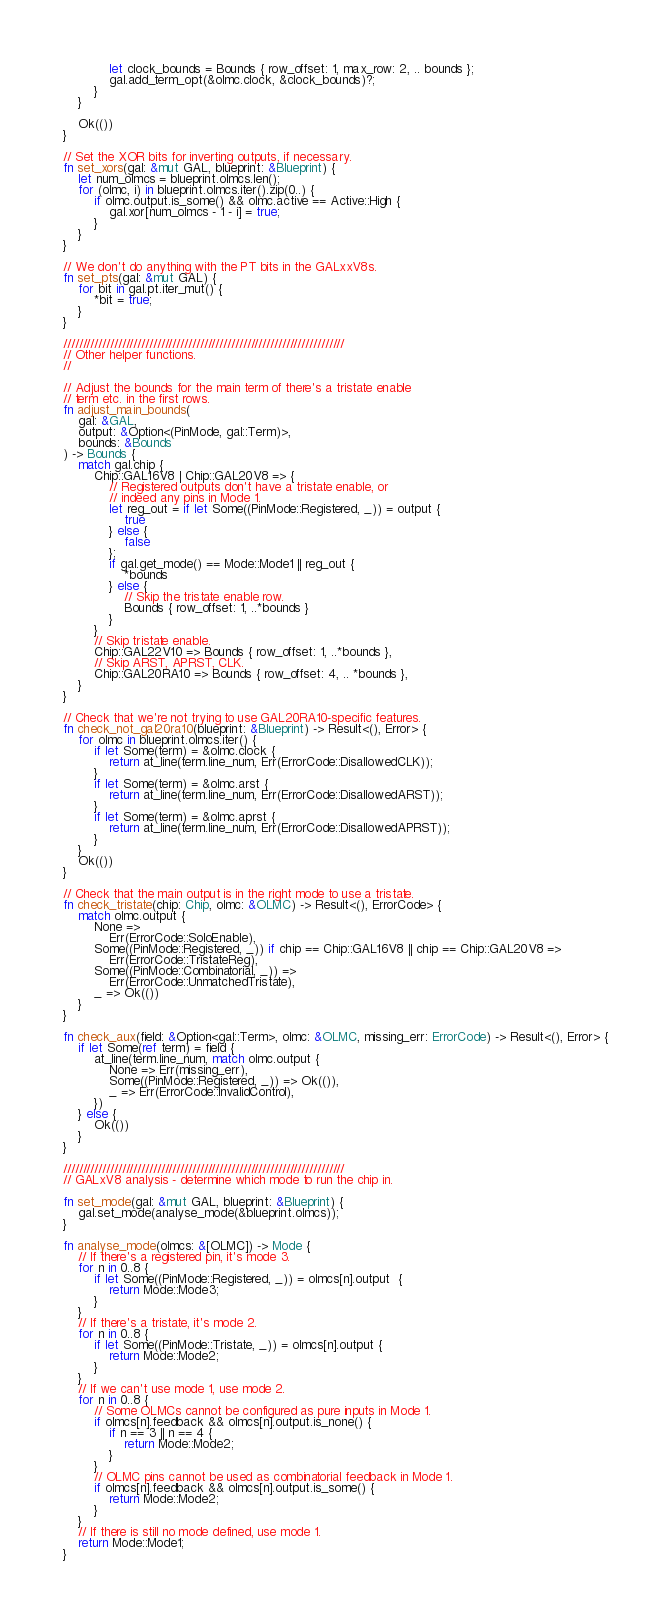Convert code to text. <code><loc_0><loc_0><loc_500><loc_500><_Rust_>            let clock_bounds = Bounds { row_offset: 1, max_row: 2, .. bounds };
            gal.add_term_opt(&olmc.clock, &clock_bounds)?;
        }
    }

    Ok(())
}

// Set the XOR bits for inverting outputs, if necessary.
fn set_xors(gal: &mut GAL, blueprint: &Blueprint) {
    let num_olmcs = blueprint.olmcs.len();
    for (olmc, i) in blueprint.olmcs.iter().zip(0..) {
        if olmc.output.is_some() && olmc.active == Active::High {
            gal.xor[num_olmcs - 1 - i] = true;
        }
    }
}

// We don't do anything with the PT bits in the GALxxV8s.
fn set_pts(gal: &mut GAL) {
    for bit in gal.pt.iter_mut() {
        *bit = true;
    }
}

////////////////////////////////////////////////////////////////////////
// Other helper functions.
//

// Adjust the bounds for the main term of there's a tristate enable
// term etc. in the first rows.
fn adjust_main_bounds(
    gal: &GAL,
    output: &Option<(PinMode, gal::Term)>,
    bounds: &Bounds
) -> Bounds {
    match gal.chip {
        Chip::GAL16V8 | Chip::GAL20V8 => {
            // Registered outputs don't have a tristate enable, or
            // indeed any pins in Mode 1.
            let reg_out = if let Some((PinMode::Registered, _)) = output {
                true
            } else {
                false
            };
            if gal.get_mode() == Mode::Mode1 || reg_out {
                *bounds
            } else {
                // Skip the tristate enable row.
                Bounds { row_offset: 1, ..*bounds }
            }
        }
        // Skip tristate enable.
        Chip::GAL22V10 => Bounds { row_offset: 1, ..*bounds },
        // Skip ARST, APRST, CLK.
        Chip::GAL20RA10 => Bounds { row_offset: 4, .. *bounds },
    }
}

// Check that we're not trying to use GAL20RA10-specific features.
fn check_not_gal20ra10(blueprint: &Blueprint) -> Result<(), Error> {
    for olmc in blueprint.olmcs.iter() {
        if let Some(term) = &olmc.clock {
            return at_line(term.line_num, Err(ErrorCode::DisallowedCLK));
        }
        if let Some(term) = &olmc.arst {
            return at_line(term.line_num, Err(ErrorCode::DisallowedARST));
        }
        if let Some(term) = &olmc.aprst {
            return at_line(term.line_num, Err(ErrorCode::DisallowedAPRST));
        }
    }
    Ok(())
}

// Check that the main output is in the right mode to use a tristate.
fn check_tristate(chip: Chip, olmc: &OLMC) -> Result<(), ErrorCode> {
    match olmc.output {
        None =>
            Err(ErrorCode::SoloEnable),
        Some((PinMode::Registered, _)) if chip == Chip::GAL16V8 || chip == Chip::GAL20V8 =>
            Err(ErrorCode::TristateReg),
        Some((PinMode::Combinatorial, _)) =>
            Err(ErrorCode::UnmatchedTristate),
        _ => Ok(())
    }
}

fn check_aux(field: &Option<gal::Term>, olmc: &OLMC, missing_err: ErrorCode) -> Result<(), Error> {
    if let Some(ref term) = field {
        at_line(term.line_num, match olmc.output {
            None => Err(missing_err),
            Some((PinMode::Registered, _)) => Ok(()),
            _ => Err(ErrorCode::InvalidControl),
        })
    } else {
        Ok(())
    }
}

////////////////////////////////////////////////////////////////////////
// GALxV8 analysis - determine which mode to run the chip in.

fn set_mode(gal: &mut GAL, blueprint: &Blueprint) {
    gal.set_mode(analyse_mode(&blueprint.olmcs));
}

fn analyse_mode(olmcs: &[OLMC]) -> Mode {
    // If there's a registered pin, it's mode 3.
    for n in 0..8 {
        if let Some((PinMode::Registered, _)) = olmcs[n].output  {
            return Mode::Mode3;
        }
    }
    // If there's a tristate, it's mode 2.
    for n in 0..8 {
        if let Some((PinMode::Tristate, _)) = olmcs[n].output {
            return Mode::Mode2;
        }
    }
    // If we can't use mode 1, use mode 2.
    for n in 0..8 {
        // Some OLMCs cannot be configured as pure inputs in Mode 1.
        if olmcs[n].feedback && olmcs[n].output.is_none() {
            if n == 3 || n == 4 {
                return Mode::Mode2;
            }
        }
        // OLMC pins cannot be used as combinatorial feedback in Mode 1.
        if olmcs[n].feedback && olmcs[n].output.is_some() {
            return Mode::Mode2;
        }
    }
    // If there is still no mode defined, use mode 1.
    return Mode::Mode1;
}
</code> 